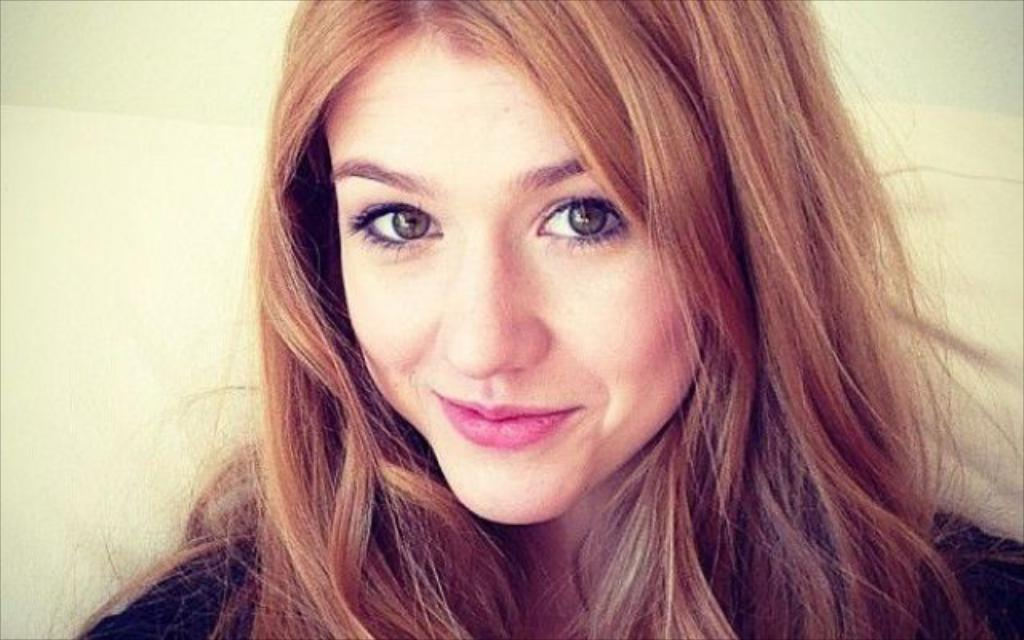What is the main subject of the picture? The main subject of the picture is a woman. What is the woman doing in the picture? The woman is smiling in the picture. What type of oil is being used by the woman in the picture? There is no oil present in the image, as it features a woman who is smiling. 